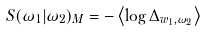Convert formula to latex. <formula><loc_0><loc_0><loc_500><loc_500>S ( \omega _ { 1 } | \omega _ { 2 } ) _ { M } = - \left \langle \log \Delta _ { w _ { 1 } , \omega _ { 2 } } \right \rangle</formula> 